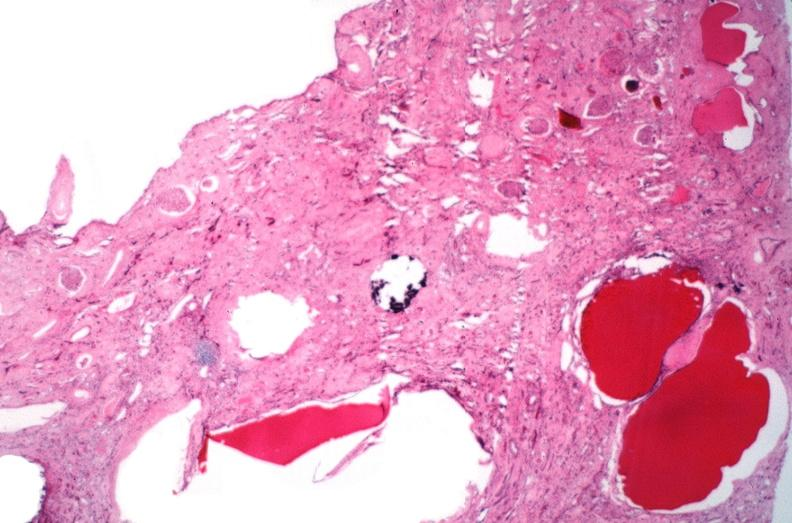does this image show kidney, adult polycystic kidney?
Answer the question using a single word or phrase. Yes 